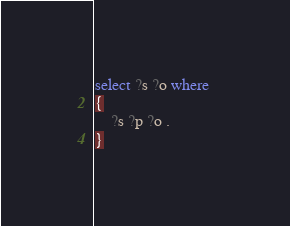<code> <loc_0><loc_0><loc_500><loc_500><_SQL_>select ?s ?o where 
{ 
	?s ?p ?o . 
}
</code> 